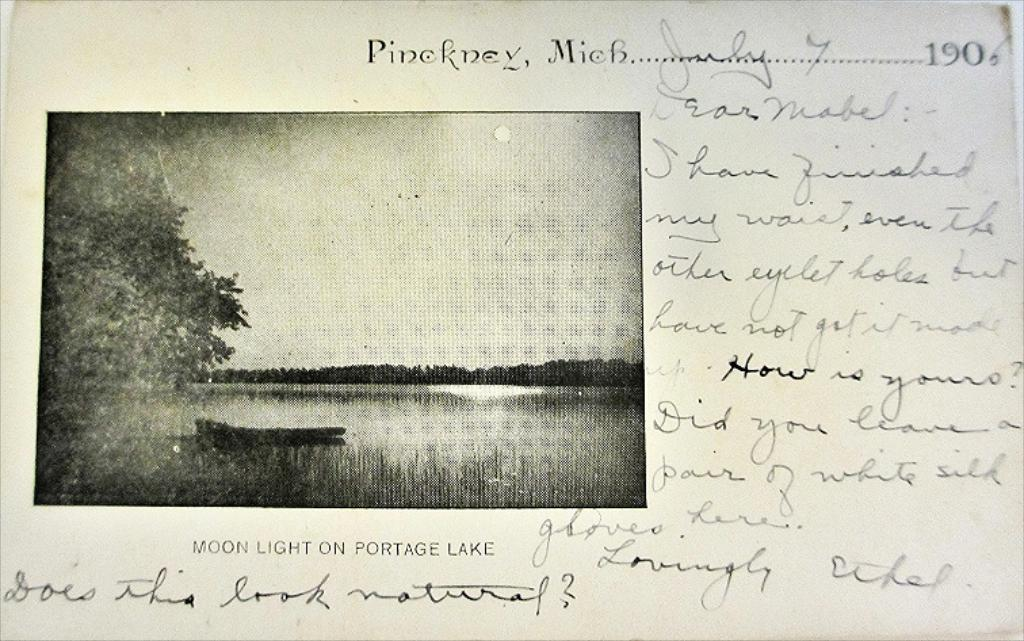What is on the right side of the image? There is a paper with text on the right side of the image. What is on the left side of the image? There is a photo on the left side of the image. What can be seen in the photo? The photo contains a boat, a sea, trees, and the sky. Is the sun visible in the photo? Yes, the sun is observable in the photo. What day of the week is depicted in the photo? The day of the week is not depicted in the photo, as it only shows a boat, a sea, trees, and the sky. Is there a hose visible in the photo? No, there is no hose present in the photo. 